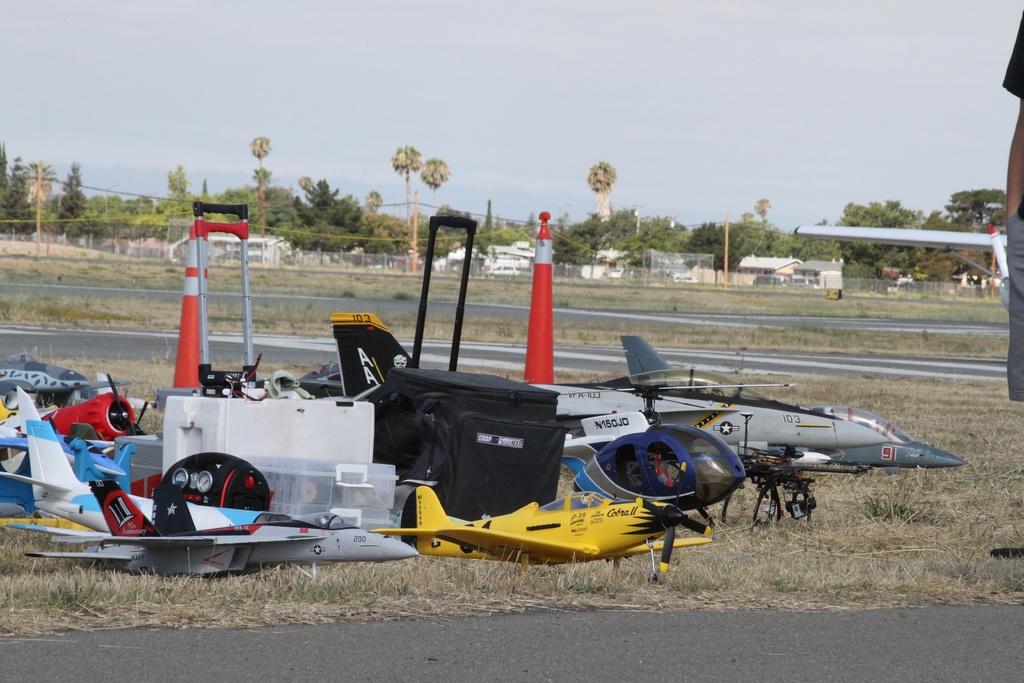What two letters are on the tail of the silver plane?
Offer a very short reply. Unanswerable. 